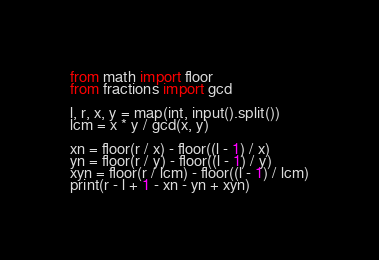<code> <loc_0><loc_0><loc_500><loc_500><_Python_>from math import floor
from fractions import gcd

l, r, x, y = map(int, input().split())
lcm = x * y / gcd(x, y)

xn = floor(r / x) - floor((l - 1) / x)
yn = floor(r / y) - floor((l - 1) / y)
xyn = floor(r / lcm) - floor((l - 1) / lcm)
print(r - l + 1 - xn - yn + xyn)
</code> 